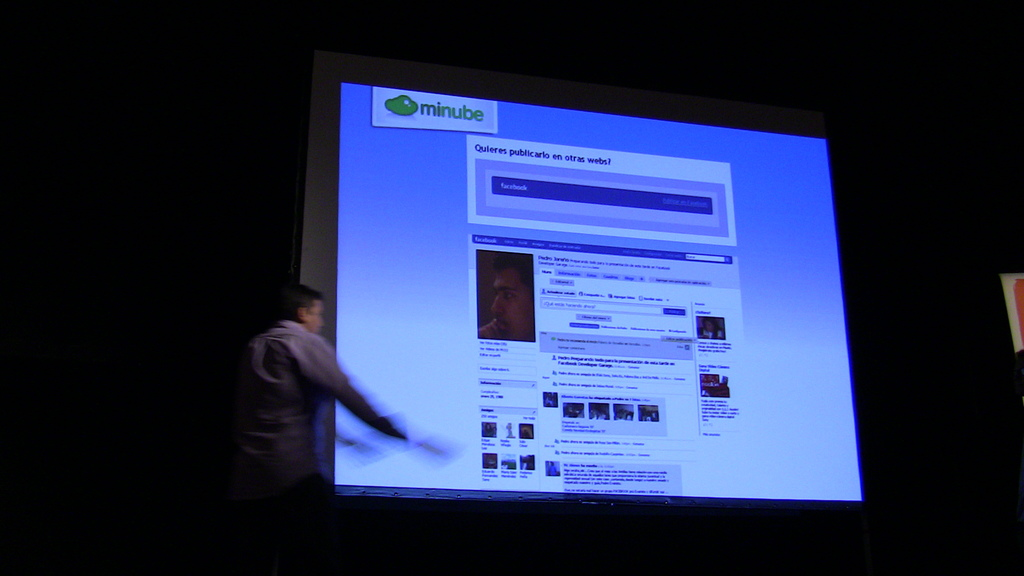Provide a one-sentence caption for the provided image. A speaker is actively engaged in a presentation in a darkened room, discussing features of the 'minube' website projected on a large screen behind him. 